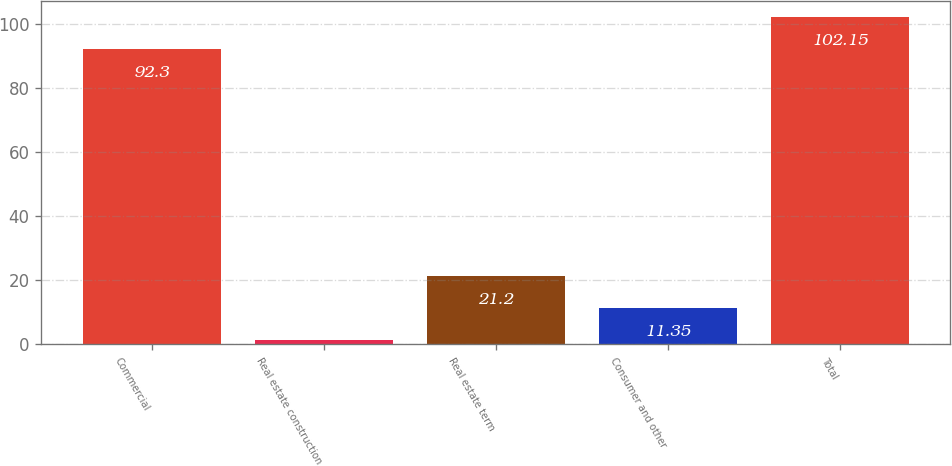Convert chart to OTSL. <chart><loc_0><loc_0><loc_500><loc_500><bar_chart><fcel>Commercial<fcel>Real estate construction<fcel>Real estate term<fcel>Consumer and other<fcel>Total<nl><fcel>92.3<fcel>1.5<fcel>21.2<fcel>11.35<fcel>102.15<nl></chart> 